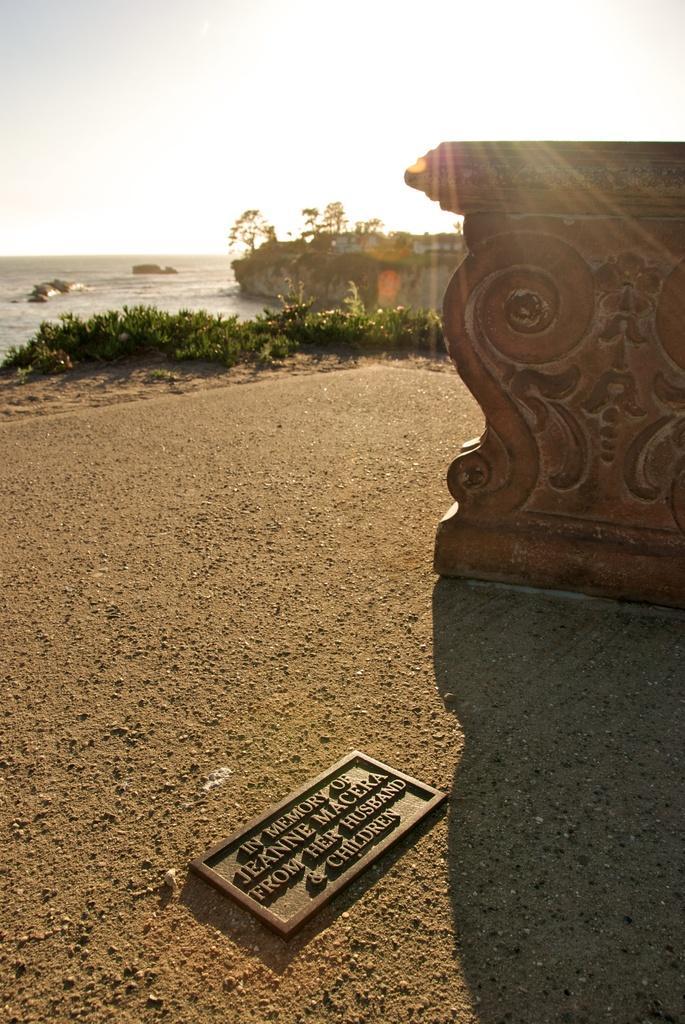Please provide a concise description of this image. In this image we can see a board on the ground, we can see the wall, we can see plants, water, stones and the sunny sky in the background. 